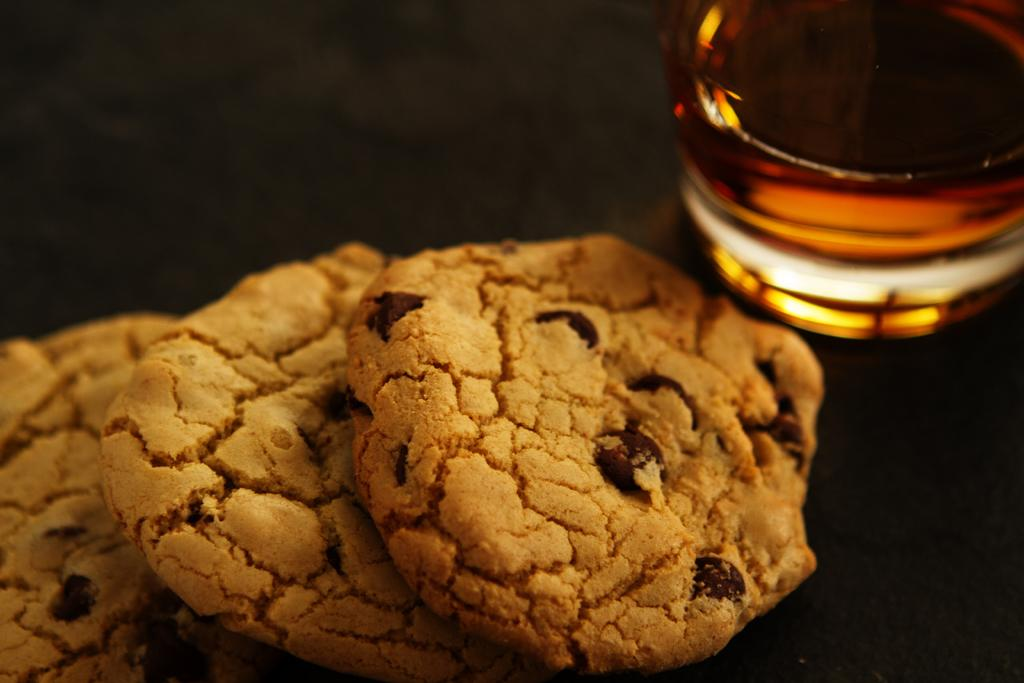What type of food can be seen in the image? There are cookies in the image. What other object is present in the image besides the cookies? There is a glass object in the image. What is the color of the surface on which the objects are placed? The objects are on a black surface. How many boys are wearing jeans in the image? There are no boys or jeans present in the image. 